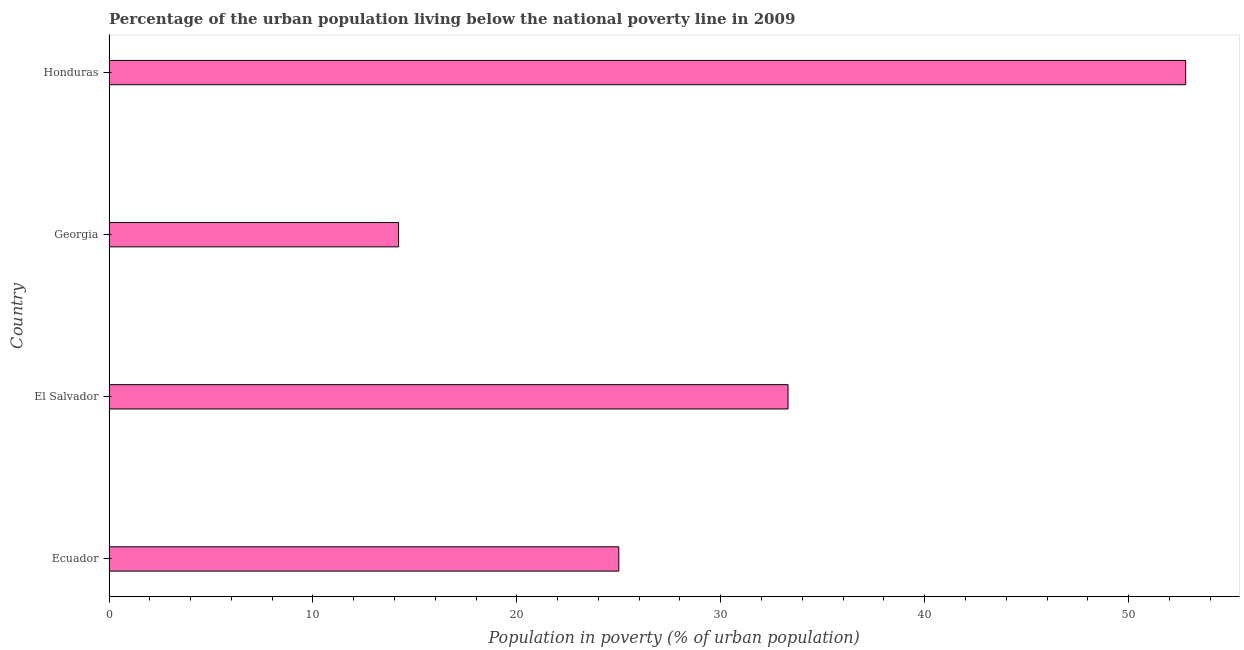Does the graph contain any zero values?
Offer a very short reply. No. What is the title of the graph?
Give a very brief answer. Percentage of the urban population living below the national poverty line in 2009. What is the label or title of the X-axis?
Your answer should be compact. Population in poverty (% of urban population). What is the label or title of the Y-axis?
Make the answer very short. Country. What is the percentage of urban population living below poverty line in Ecuador?
Provide a short and direct response. 25. Across all countries, what is the maximum percentage of urban population living below poverty line?
Give a very brief answer. 52.8. Across all countries, what is the minimum percentage of urban population living below poverty line?
Ensure brevity in your answer.  14.2. In which country was the percentage of urban population living below poverty line maximum?
Provide a short and direct response. Honduras. In which country was the percentage of urban population living below poverty line minimum?
Your answer should be very brief. Georgia. What is the sum of the percentage of urban population living below poverty line?
Offer a very short reply. 125.3. What is the average percentage of urban population living below poverty line per country?
Ensure brevity in your answer.  31.32. What is the median percentage of urban population living below poverty line?
Offer a terse response. 29.15. In how many countries, is the percentage of urban population living below poverty line greater than 2 %?
Your answer should be compact. 4. What is the ratio of the percentage of urban population living below poverty line in Georgia to that in Honduras?
Your answer should be very brief. 0.27. Is the difference between the percentage of urban population living below poverty line in Georgia and Honduras greater than the difference between any two countries?
Provide a succinct answer. Yes. What is the difference between the highest and the lowest percentage of urban population living below poverty line?
Offer a very short reply. 38.6. Are all the bars in the graph horizontal?
Make the answer very short. Yes. What is the Population in poverty (% of urban population) of Ecuador?
Provide a short and direct response. 25. What is the Population in poverty (% of urban population) of El Salvador?
Give a very brief answer. 33.3. What is the Population in poverty (% of urban population) of Honduras?
Ensure brevity in your answer.  52.8. What is the difference between the Population in poverty (% of urban population) in Ecuador and El Salvador?
Give a very brief answer. -8.3. What is the difference between the Population in poverty (% of urban population) in Ecuador and Georgia?
Provide a short and direct response. 10.8. What is the difference between the Population in poverty (% of urban population) in Ecuador and Honduras?
Ensure brevity in your answer.  -27.8. What is the difference between the Population in poverty (% of urban population) in El Salvador and Georgia?
Give a very brief answer. 19.1. What is the difference between the Population in poverty (% of urban population) in El Salvador and Honduras?
Your answer should be very brief. -19.5. What is the difference between the Population in poverty (% of urban population) in Georgia and Honduras?
Offer a very short reply. -38.6. What is the ratio of the Population in poverty (% of urban population) in Ecuador to that in El Salvador?
Provide a succinct answer. 0.75. What is the ratio of the Population in poverty (% of urban population) in Ecuador to that in Georgia?
Give a very brief answer. 1.76. What is the ratio of the Population in poverty (% of urban population) in Ecuador to that in Honduras?
Your answer should be compact. 0.47. What is the ratio of the Population in poverty (% of urban population) in El Salvador to that in Georgia?
Ensure brevity in your answer.  2.35. What is the ratio of the Population in poverty (% of urban population) in El Salvador to that in Honduras?
Your answer should be compact. 0.63. What is the ratio of the Population in poverty (% of urban population) in Georgia to that in Honduras?
Offer a terse response. 0.27. 